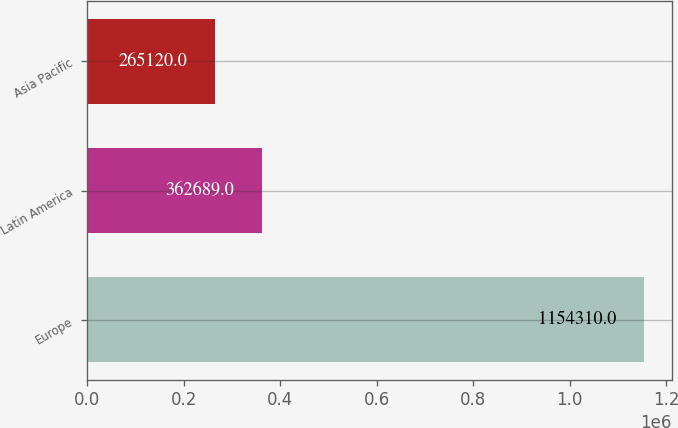Convert chart. <chart><loc_0><loc_0><loc_500><loc_500><bar_chart><fcel>Europe<fcel>Latin America<fcel>Asia Pacific<nl><fcel>1.15431e+06<fcel>362689<fcel>265120<nl></chart> 